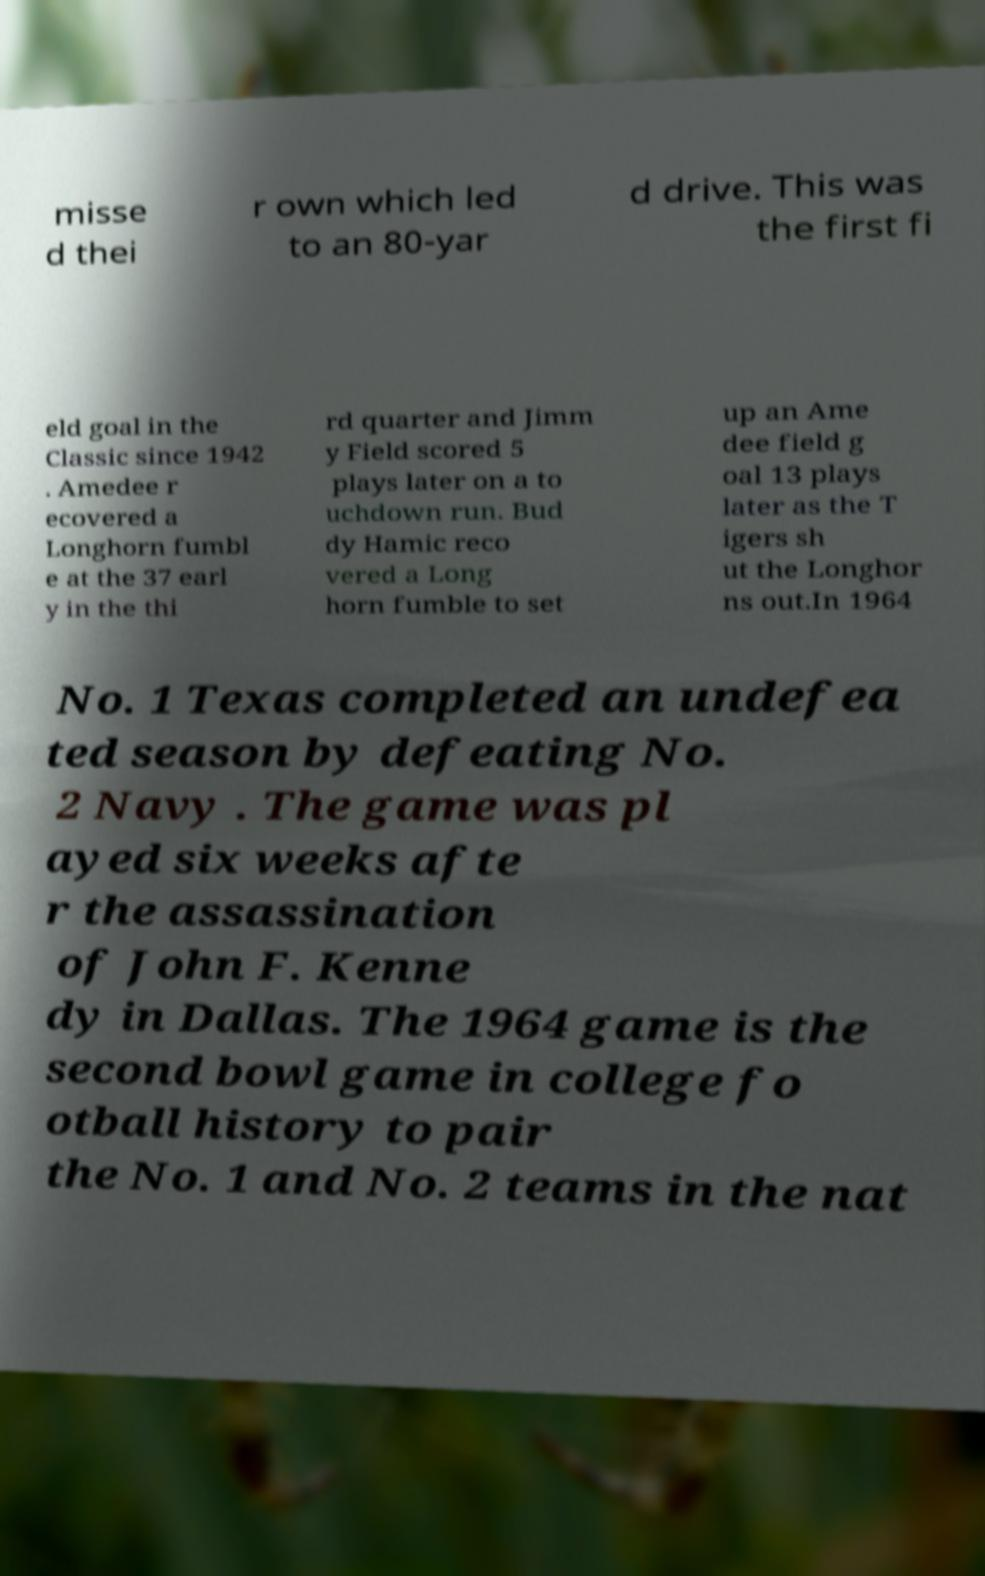Please read and relay the text visible in this image. What does it say? misse d thei r own which led to an 80-yar d drive. This was the first fi eld goal in the Classic since 1942 . Amedee r ecovered a Longhorn fumbl e at the 37 earl y in the thi rd quarter and Jimm y Field scored 5 plays later on a to uchdown run. Bud dy Hamic reco vered a Long horn fumble to set up an Ame dee field g oal 13 plays later as the T igers sh ut the Longhor ns out.In 1964 No. 1 Texas completed an undefea ted season by defeating No. 2 Navy . The game was pl ayed six weeks afte r the assassination of John F. Kenne dy in Dallas. The 1964 game is the second bowl game in college fo otball history to pair the No. 1 and No. 2 teams in the nat 